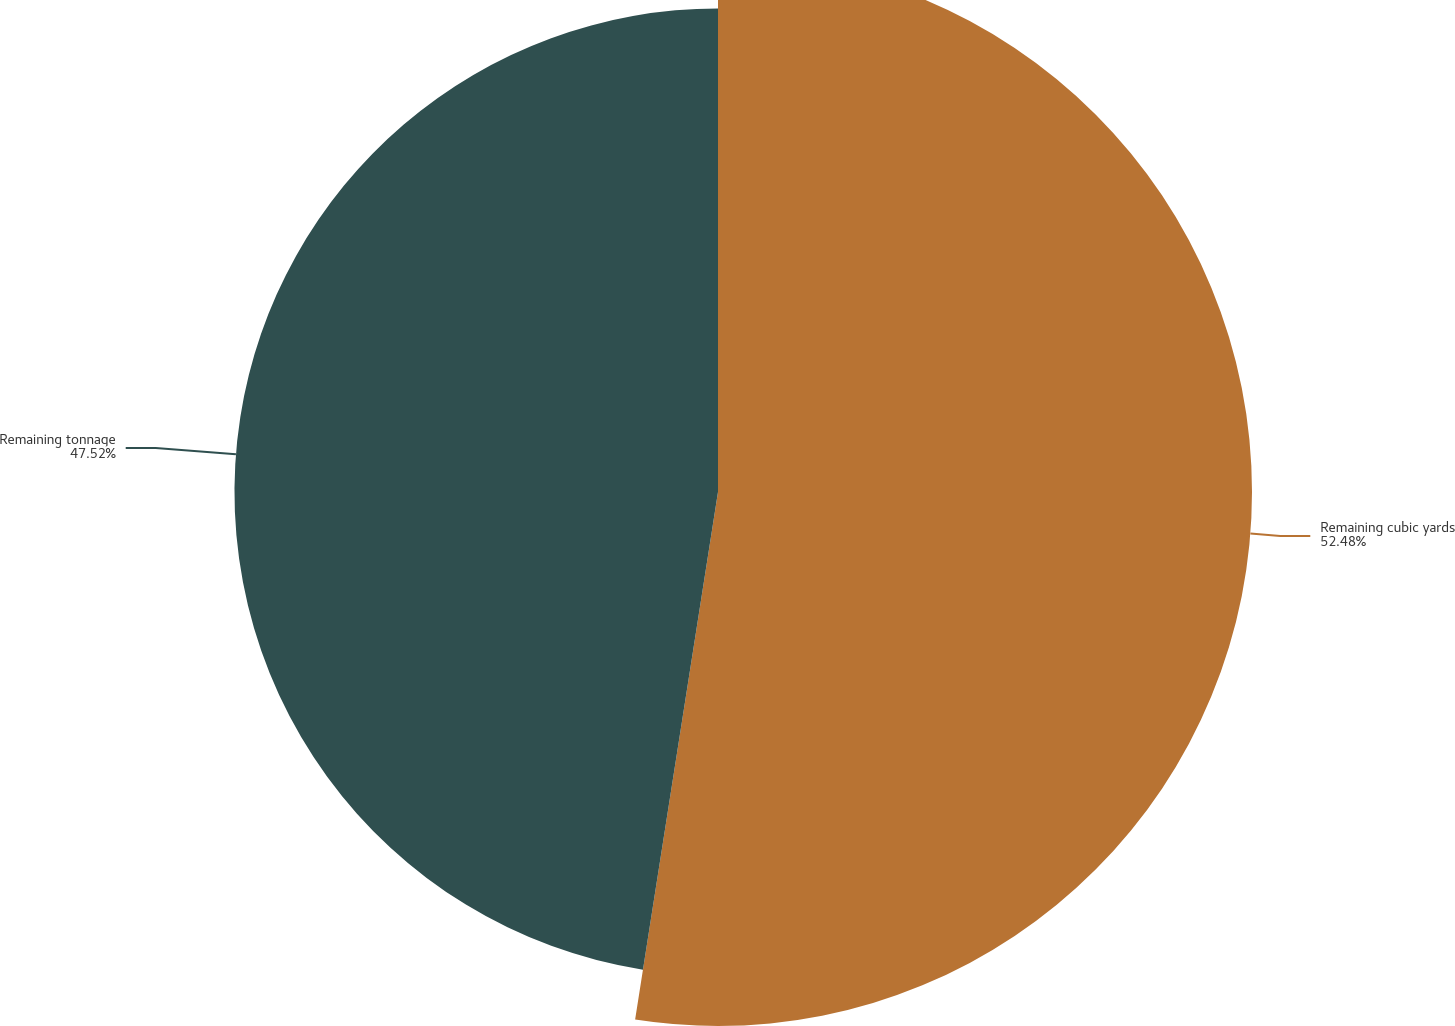Convert chart. <chart><loc_0><loc_0><loc_500><loc_500><pie_chart><fcel>Remaining cubic yards<fcel>Remaining tonnage<nl><fcel>52.48%<fcel>47.52%<nl></chart> 